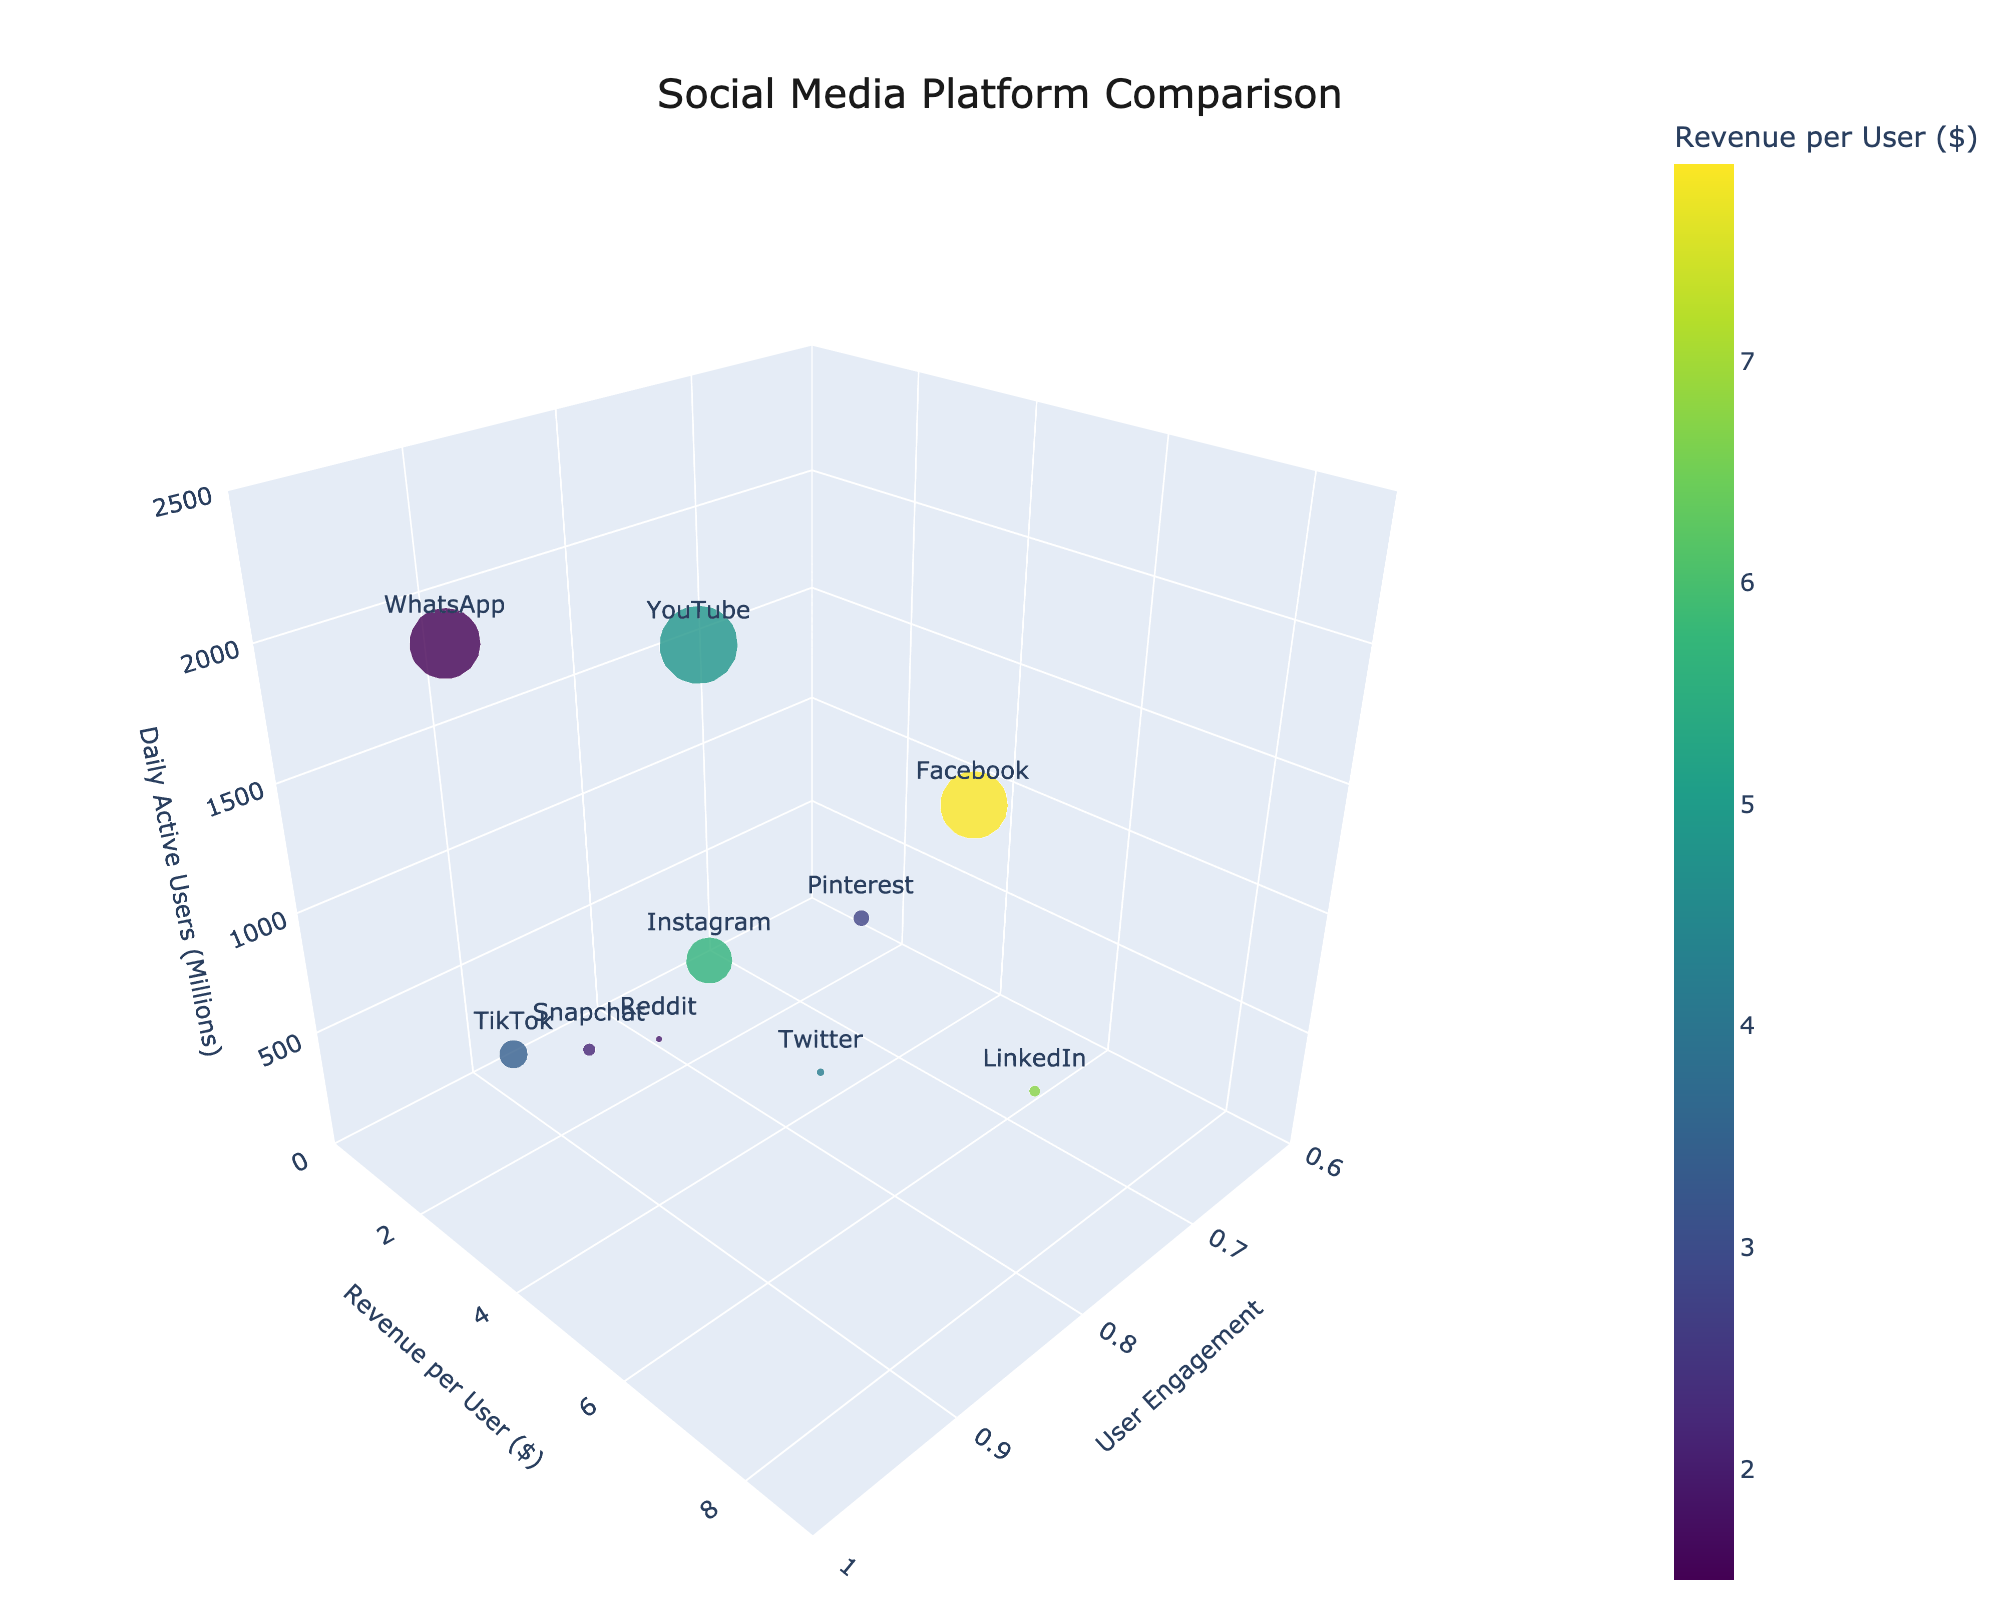How many platforms have a user engagement greater than 0.9? Identify platforms with user engagement values greater than 0.9: Instagram (0.92), TikTok (0.97), WhatsApp (0.93). The number of such platforms is 3.
Answer: 3 Which platform has the highest daily active users? Look at the z-axis (Daily Active Users) and identify the highest value. The platform with the highest value is YouTube with 2200 million daily active users.
Answer: YouTube How does Snapchat compare to Pinterest in terms of revenue per user? Check the y-axis (Revenue per User) for both Snapchat and Pinterest. Snapchat has a revenue per user of 2.15, while Pinterest has a revenue per user of 2.80. Therefore, Pinterest has a higher revenue per user than Snapchat.
Answer: Pinterest has higher revenue per user Which platforms have a revenue per user less than $3? Identify platforms where the y-axis (Revenue per User) values are below $3: TikTok (3.42), Pinterest (2.80), Snapchat (2.15), Reddit (1.95), WhatsApp (1.50). These platforms are TikTok, Pinterest, Snapchat, Reddit, and WhatsApp.
Answer: TikTok, Pinterest, Snapchat, Reddit, WhatsApp What is the average revenue per user across all platforms? Sum the revenue per user for all platforms and divide by the number of platforms. Sum is 7.89 + 5.63 + 3.42 + 4.21 + 6.75 + 2.80 + 2.15 + 1.95 + 1.50 + 4.85 = 41.15. Divide 41.15 by 10 platforms.
Answer: 4.115 Which platform has the lowest user engagement? Look at the x-axis (User Engagement) and identify the lowest value. LinkedIn has the lowest user engagement with a value of 0.72.
Answer: LinkedIn Compare Facebook and Instagram in terms of daily active users. Check the z-axis (Daily Active Users) for both Facebook and Instagram. Facebook has 1900 million, while Instagram has 1300 million daily active users. Hence, Facebook has more daily active users than Instagram.
Answer: Facebook has more daily active users Does any platform have both high user engagement (above 0.9) and high revenue per user (above $5)? Identify platforms with engagement > 0.9 and revenue per user > $5: Instagram (0.92, 5.63). Instagram meets both criteria.
Answer: Yes, Instagram What is the combined daily active user count for platforms with a user engagement greater than 0.85? Sum the daily active users for platforms where engagement > 0.85: Facebook (1900), Instagram (1300), TikTok (800), WhatsApp (2000), YouTube (2200). Sum is 1900 + 1300 + 800 + 2000 + 2200 = 8200 million daily active users.
Answer: 8200 Which platform has a color indicating the highest revenue per user on the plot? The plot's color scale is based on revenue per user. Identify the platform with the darkest color, which correlates with the highest revenue. Facebook, with $7.89 per user, would have the darkest shade.
Answer: Facebook 